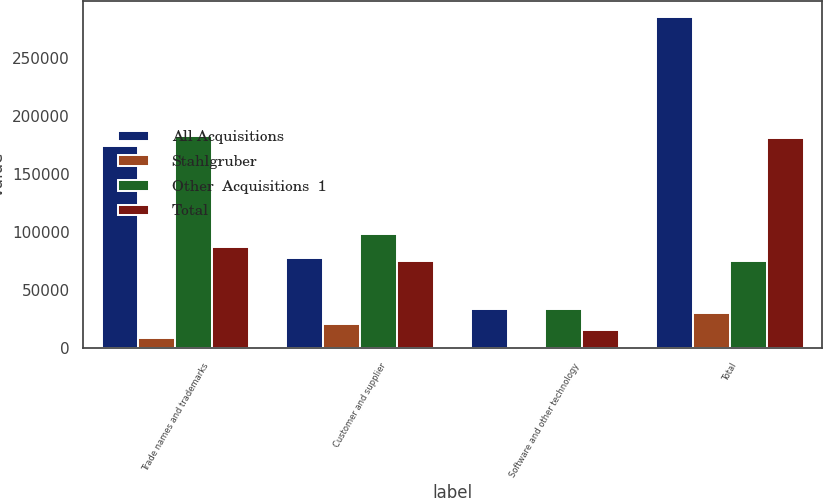Convert chart. <chart><loc_0><loc_0><loc_500><loc_500><stacked_bar_chart><ecel><fcel>Trade names and trademarks<fcel>Customer and supplier<fcel>Software and other technology<fcel>Total<nl><fcel>All Acquisitions<fcel>173946<fcel>77980<fcel>33329<fcel>285255<nl><fcel>Stahlgruber<fcel>8870<fcel>20779<fcel>376<fcel>30025<nl><fcel>Other  Acquisitions  1<fcel>182816<fcel>98759<fcel>33705<fcel>75450<nl><fcel>Total<fcel>87306<fcel>75450<fcel>15757<fcel>181216<nl></chart> 